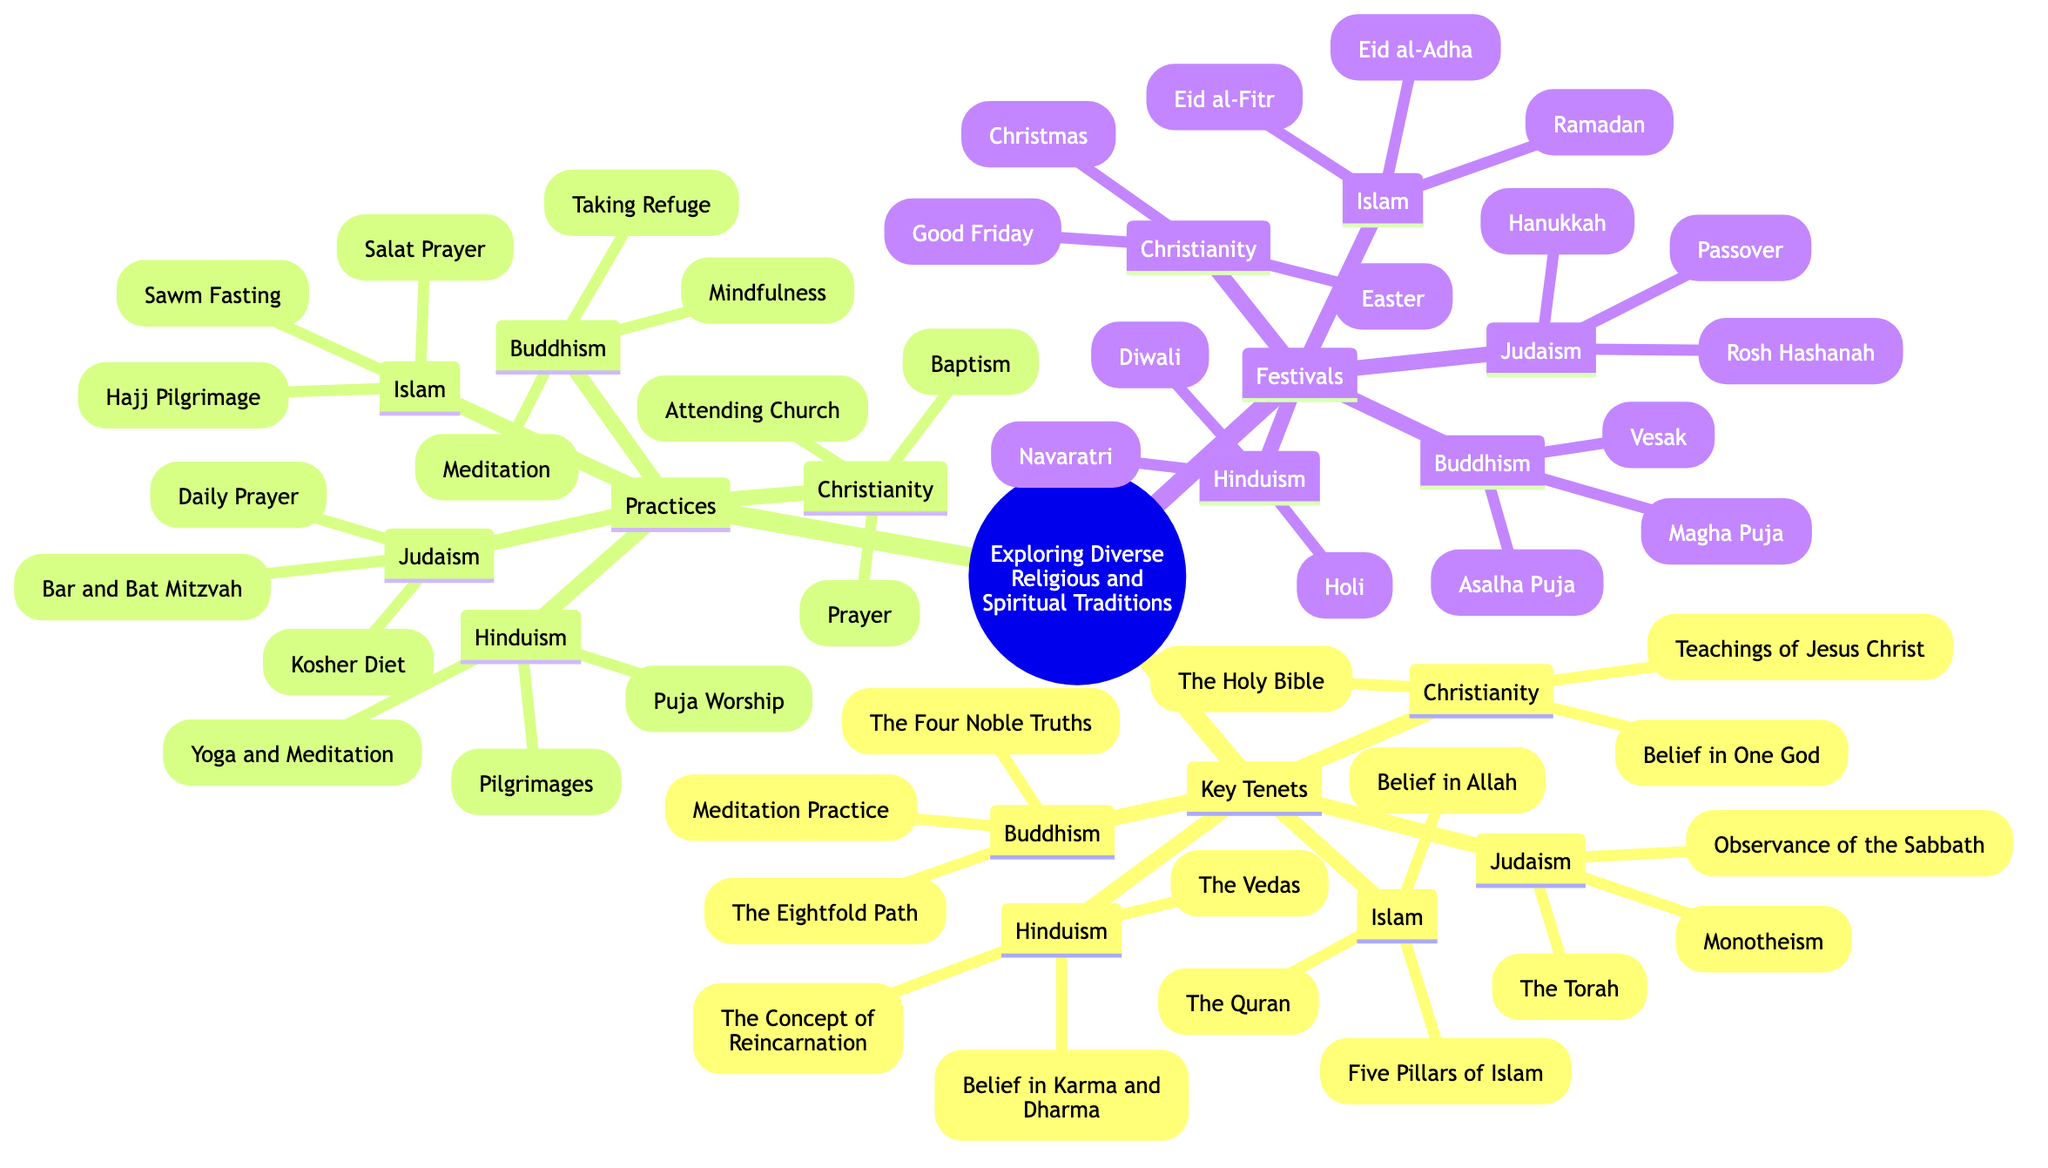What are the key tenets of Buddhism? To find the answer, I look under the "Key Tenets" section in the diagram. Buddhism lists the Four Noble Truths, the Eightfold Path, and Meditation Practice.
Answer: The Four Noble Truths, the Eightfold Path, Meditation Practice How many major religions are listed in the diagram? I can count the nodes under the "Key Tenets," which include Christianity, Islam, Hinduism, Buddhism, and Judaism. There are five major religions.
Answer: 5 What practice is common in both Christianity and Judaism? I check the "Practices" section for both Christianity and Judaism. Both include "Prayer" as a common practice.
Answer: Prayer What is the main scripture of Islam? I refer to the "Key Tenets" under Islam, where "The Quran" is listed as the main scripture.
Answer: The Quran Which festival is celebrated in Hinduism during the spring? In the "Festivals" section, I find the mention of "Holi," which is noted as a festival celebrated in Hinduism during the spring.
Answer: Holi What do all religions represented in this diagram have in common? I can analyze the main branches of the diagram and see that they all encompass belief systems, practices, and festivals. This highlights the diversity but also the shared aspect of spirituality among them.
Answer: Belief systems Which religion's key tenets include the concept of reincarnation? I check the "Key Tenets" under Hinduism, which mentions "The Concept of Reincarnation" as a key tenet.
Answer: Hinduism How many festivals are associated with Buddhism? I look under the "Festivals" section and find three festivals mentioned for Buddhism: Vesak, Magha Puja, and Asalha Puja.
Answer: 3 What is a common practice in both Buddhism and Hinduism? I explore the "Practices" section and see that both Buddhism and Hinduism include "Meditation."
Answer: Meditation 